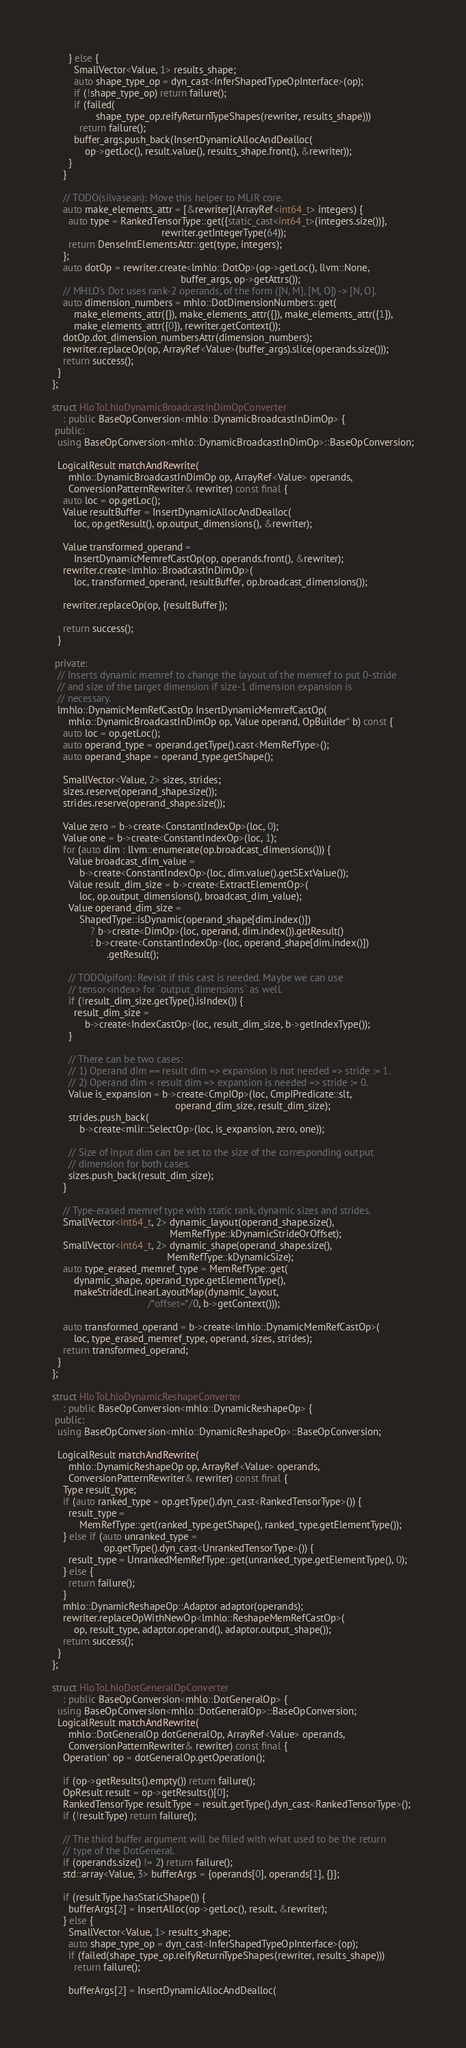<code> <loc_0><loc_0><loc_500><loc_500><_C++_>      } else {
        SmallVector<Value, 1> results_shape;
        auto shape_type_op = dyn_cast<InferShapedTypeOpInterface>(op);
        if (!shape_type_op) return failure();
        if (failed(
                shape_type_op.reifyReturnTypeShapes(rewriter, results_shape)))
          return failure();
        buffer_args.push_back(InsertDynamicAllocAndDealloc(
            op->getLoc(), result.value(), results_shape.front(), &rewriter));
      }
    }

    // TODO(silvasean): Move this helper to MLIR core.
    auto make_elements_attr = [&rewriter](ArrayRef<int64_t> integers) {
      auto type = RankedTensorType::get({static_cast<int64_t>(integers.size())},
                                        rewriter.getIntegerType(64));
      return DenseIntElementsAttr::get(type, integers);
    };
    auto dotOp = rewriter.create<lmhlo::DotOp>(op->getLoc(), llvm::None,
                                               buffer_args, op->getAttrs());
    // MHLO's Dot uses rank-2 operands, of the form ([N, M], [M, O]) -> [N, O].
    auto dimension_numbers = mhlo::DotDimensionNumbers::get(
        make_elements_attr({}), make_elements_attr({}), make_elements_attr({1}),
        make_elements_attr({0}), rewriter.getContext());
    dotOp.dot_dimension_numbersAttr(dimension_numbers);
    rewriter.replaceOp(op, ArrayRef<Value>(buffer_args).slice(operands.size()));
    return success();
  }
};

struct HloToLhloDynamicBroadcastInDimOpConverter
    : public BaseOpConversion<mhlo::DynamicBroadcastInDimOp> {
 public:
  using BaseOpConversion<mhlo::DynamicBroadcastInDimOp>::BaseOpConversion;

  LogicalResult matchAndRewrite(
      mhlo::DynamicBroadcastInDimOp op, ArrayRef<Value> operands,
      ConversionPatternRewriter& rewriter) const final {
    auto loc = op.getLoc();
    Value resultBuffer = InsertDynamicAllocAndDealloc(
        loc, op.getResult(), op.output_dimensions(), &rewriter);

    Value transformed_operand =
        InsertDynamicMemrefCastOp(op, operands.front(), &rewriter);
    rewriter.create<lmhlo::BroadcastInDimOp>(
        loc, transformed_operand, resultBuffer, op.broadcast_dimensions());

    rewriter.replaceOp(op, {resultBuffer});

    return success();
  }

 private:
  // Inserts dynamic memref to change the layout of the memref to put 0-stride
  // and size of the target dimension if size-1 dimension expansion is
  // necessary.
  lmhlo::DynamicMemRefCastOp InsertDynamicMemrefCastOp(
      mhlo::DynamicBroadcastInDimOp op, Value operand, OpBuilder* b) const {
    auto loc = op.getLoc();
    auto operand_type = operand.getType().cast<MemRefType>();
    auto operand_shape = operand_type.getShape();

    SmallVector<Value, 2> sizes, strides;
    sizes.reserve(operand_shape.size());
    strides.reserve(operand_shape.size());

    Value zero = b->create<ConstantIndexOp>(loc, 0);
    Value one = b->create<ConstantIndexOp>(loc, 1);
    for (auto dim : llvm::enumerate(op.broadcast_dimensions())) {
      Value broadcast_dim_value =
          b->create<ConstantIndexOp>(loc, dim.value().getSExtValue());
      Value result_dim_size = b->create<ExtractElementOp>(
          loc, op.output_dimensions(), broadcast_dim_value);
      Value operand_dim_size =
          ShapedType::isDynamic(operand_shape[dim.index()])
              ? b->create<DimOp>(loc, operand, dim.index()).getResult()
              : b->create<ConstantIndexOp>(loc, operand_shape[dim.index()])
                    .getResult();

      // TODO(pifon): Revisit if this cast is needed. Maybe we can use
      // tensor<index> for `output_dimensions` as well.
      if (!result_dim_size.getType().isIndex()) {
        result_dim_size =
            b->create<IndexCastOp>(loc, result_dim_size, b->getIndexType());
      }

      // There can be two cases:
      // 1) Operand dim == result dim => expansion is not needed => stride := 1.
      // 2) Operand dim < result dim => expansion is needed => stride := 0.
      Value is_expansion = b->create<CmpIOp>(loc, CmpIPredicate::slt,
                                             operand_dim_size, result_dim_size);
      strides.push_back(
          b->create<mlir::SelectOp>(loc, is_expansion, zero, one));

      // Size of input dim can be set to the size of the corresponding output
      // dimension for both cases.
      sizes.push_back(result_dim_size);
    }

    // Type-erased memref type with static rank, dynamic sizes and strides.
    SmallVector<int64_t, 2> dynamic_layout(operand_shape.size(),
                                           MemRefType::kDynamicStrideOrOffset);
    SmallVector<int64_t, 2> dynamic_shape(operand_shape.size(),
                                          MemRefType::kDynamicSize);
    auto type_erased_memref_type = MemRefType::get(
        dynamic_shape, operand_type.getElementType(),
        makeStridedLinearLayoutMap(dynamic_layout,
                                   /*offset=*/0, b->getContext()));

    auto transformed_operand = b->create<lmhlo::DynamicMemRefCastOp>(
        loc, type_erased_memref_type, operand, sizes, strides);
    return transformed_operand;
  }
};

struct HloToLhloDynamicReshapeConverter
    : public BaseOpConversion<mhlo::DynamicReshapeOp> {
 public:
  using BaseOpConversion<mhlo::DynamicReshapeOp>::BaseOpConversion;

  LogicalResult matchAndRewrite(
      mhlo::DynamicReshapeOp op, ArrayRef<Value> operands,
      ConversionPatternRewriter& rewriter) const final {
    Type result_type;
    if (auto ranked_type = op.getType().dyn_cast<RankedTensorType>()) {
      result_type =
          MemRefType::get(ranked_type.getShape(), ranked_type.getElementType());
    } else if (auto unranked_type =
                   op.getType().dyn_cast<UnrankedTensorType>()) {
      result_type = UnrankedMemRefType::get(unranked_type.getElementType(), 0);
    } else {
      return failure();
    }
    mhlo::DynamicReshapeOp::Adaptor adaptor(operands);
    rewriter.replaceOpWithNewOp<lmhlo::ReshapeMemRefCastOp>(
        op, result_type, adaptor.operand(), adaptor.output_shape());
    return success();
  }
};

struct HloToLhloDotGeneralOpConverter
    : public BaseOpConversion<mhlo::DotGeneralOp> {
  using BaseOpConversion<mhlo::DotGeneralOp>::BaseOpConversion;
  LogicalResult matchAndRewrite(
      mhlo::DotGeneralOp dotGeneralOp, ArrayRef<Value> operands,
      ConversionPatternRewriter& rewriter) const final {
    Operation* op = dotGeneralOp.getOperation();

    if (op->getResults().empty()) return failure();
    OpResult result = op->getResults()[0];
    RankedTensorType resultType = result.getType().dyn_cast<RankedTensorType>();
    if (!resultType) return failure();

    // The third buffer argument will be filled with what used to be the return
    // type of the DotGeneral.
    if (operands.size() != 2) return failure();
    std::array<Value, 3> bufferArgs = {operands[0], operands[1], {}};

    if (resultType.hasStaticShape()) {
      bufferArgs[2] = InsertAlloc(op->getLoc(), result, &rewriter);
    } else {
      SmallVector<Value, 1> results_shape;
      auto shape_type_op = dyn_cast<InferShapedTypeOpInterface>(op);
      if (failed(shape_type_op.reifyReturnTypeShapes(rewriter, results_shape)))
        return failure();

      bufferArgs[2] = InsertDynamicAllocAndDealloc(</code> 